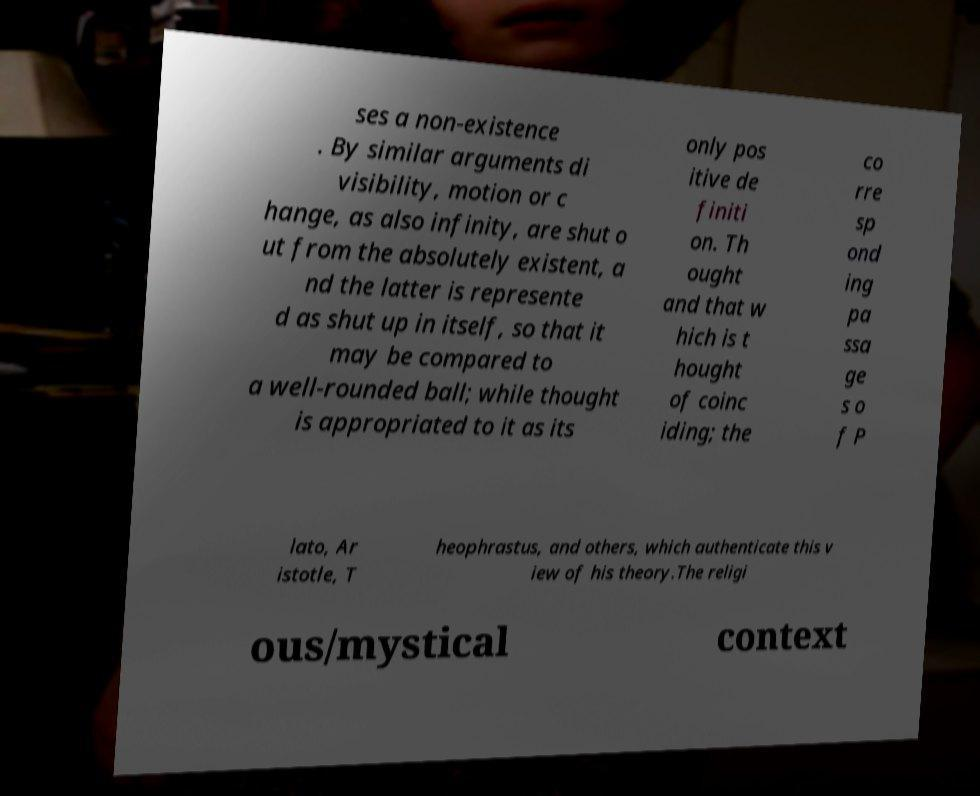Can you accurately transcribe the text from the provided image for me? ses a non-existence . By similar arguments di visibility, motion or c hange, as also infinity, are shut o ut from the absolutely existent, a nd the latter is represente d as shut up in itself, so that it may be compared to a well-rounded ball; while thought is appropriated to it as its only pos itive de finiti on. Th ought and that w hich is t hought of coinc iding; the co rre sp ond ing pa ssa ge s o f P lato, Ar istotle, T heophrastus, and others, which authenticate this v iew of his theory.The religi ous/mystical context 